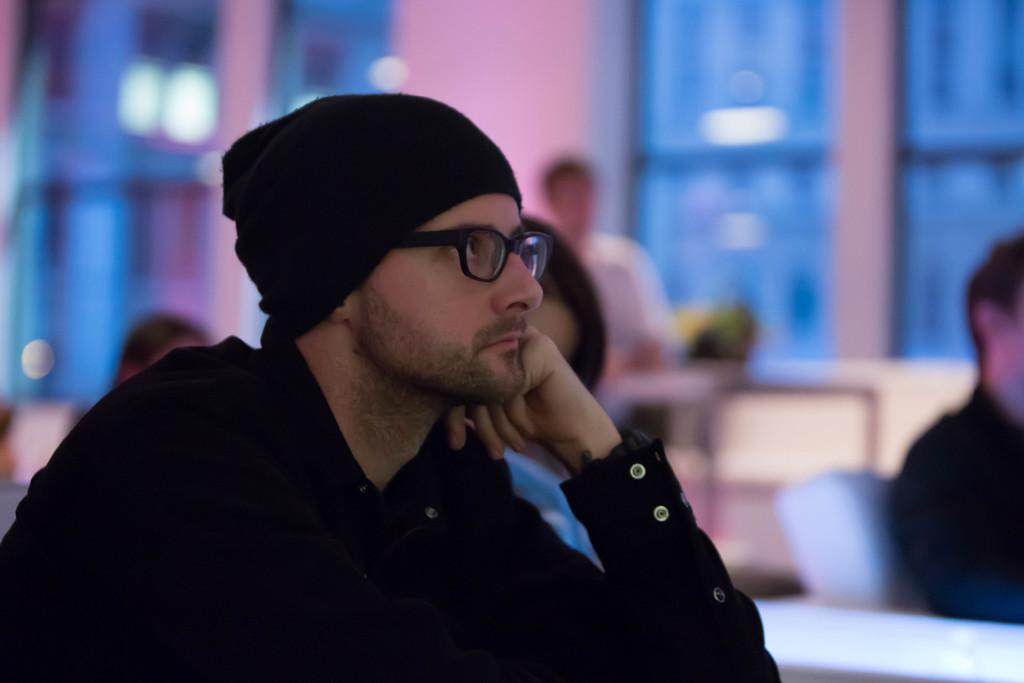What is the person in the image doing? The person is sitting in the image. What is the person wearing on their upper body? The person is wearing a black dress. What type of eyewear is the person wearing? The person is wearing specs. What type of headwear is the person wearing? The person is wearing a cap. What can be seen behind the person? There are windows behind the person. What type of lettuce is the person touching in the image? There is no lettuce present in the image, and the person is not touching anything. 